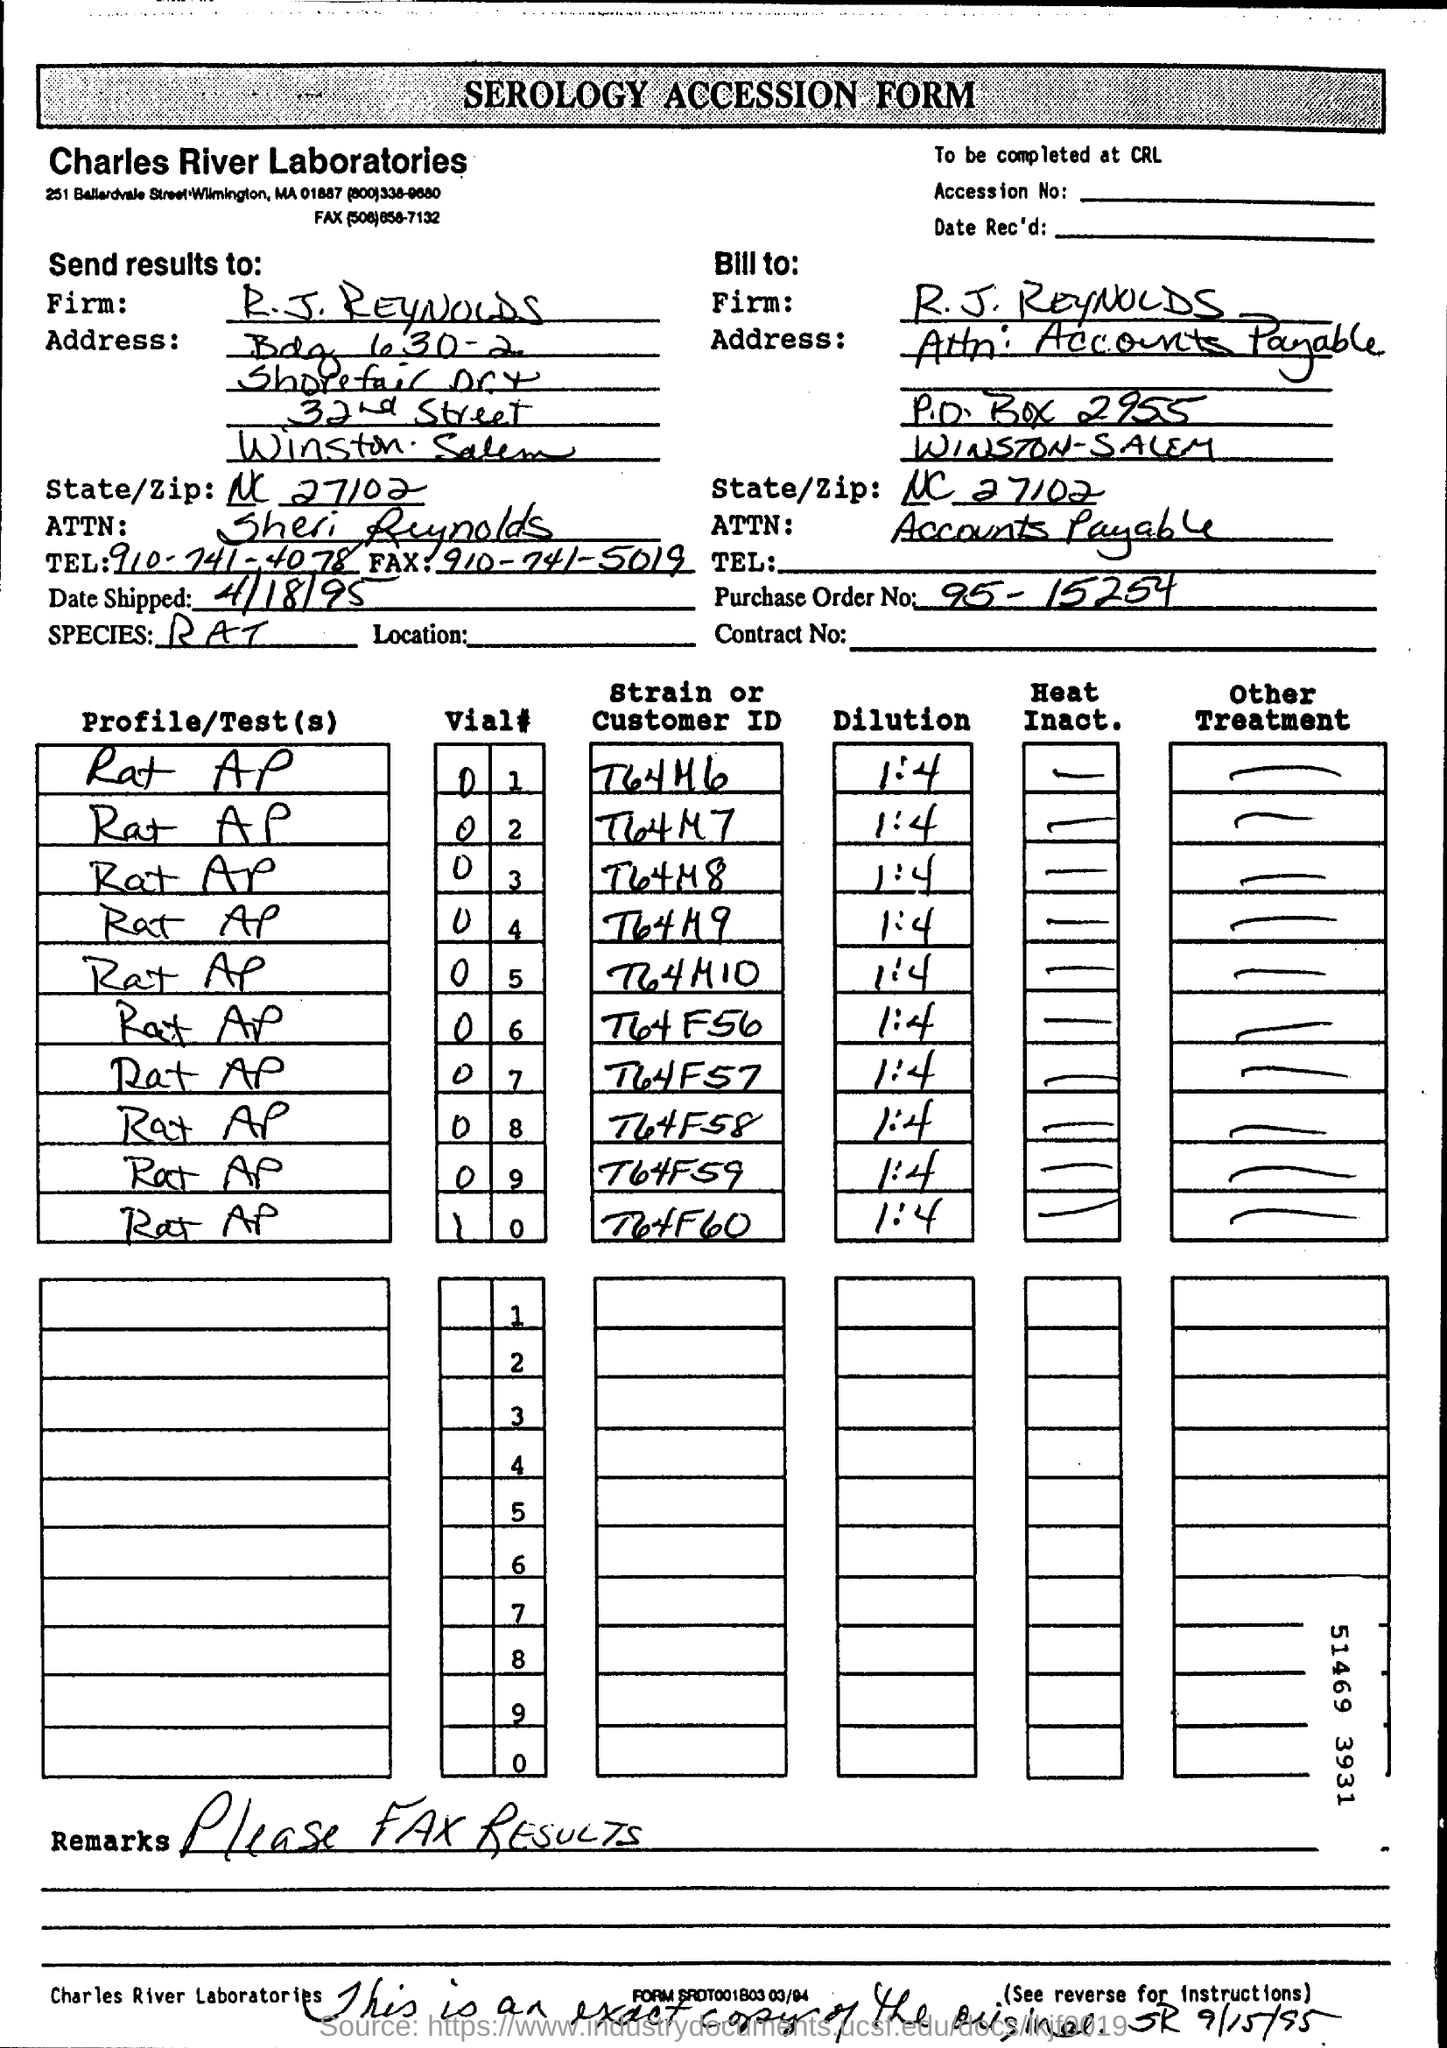Whats the name of form?
Your answer should be very brief. SEROLOGY ACCESSION FORM. What  is the Purchase Oder No given?
Ensure brevity in your answer.  95-15254. What is the name of Laboratories in form?
Your answer should be very brief. Charles River Laboratories. 